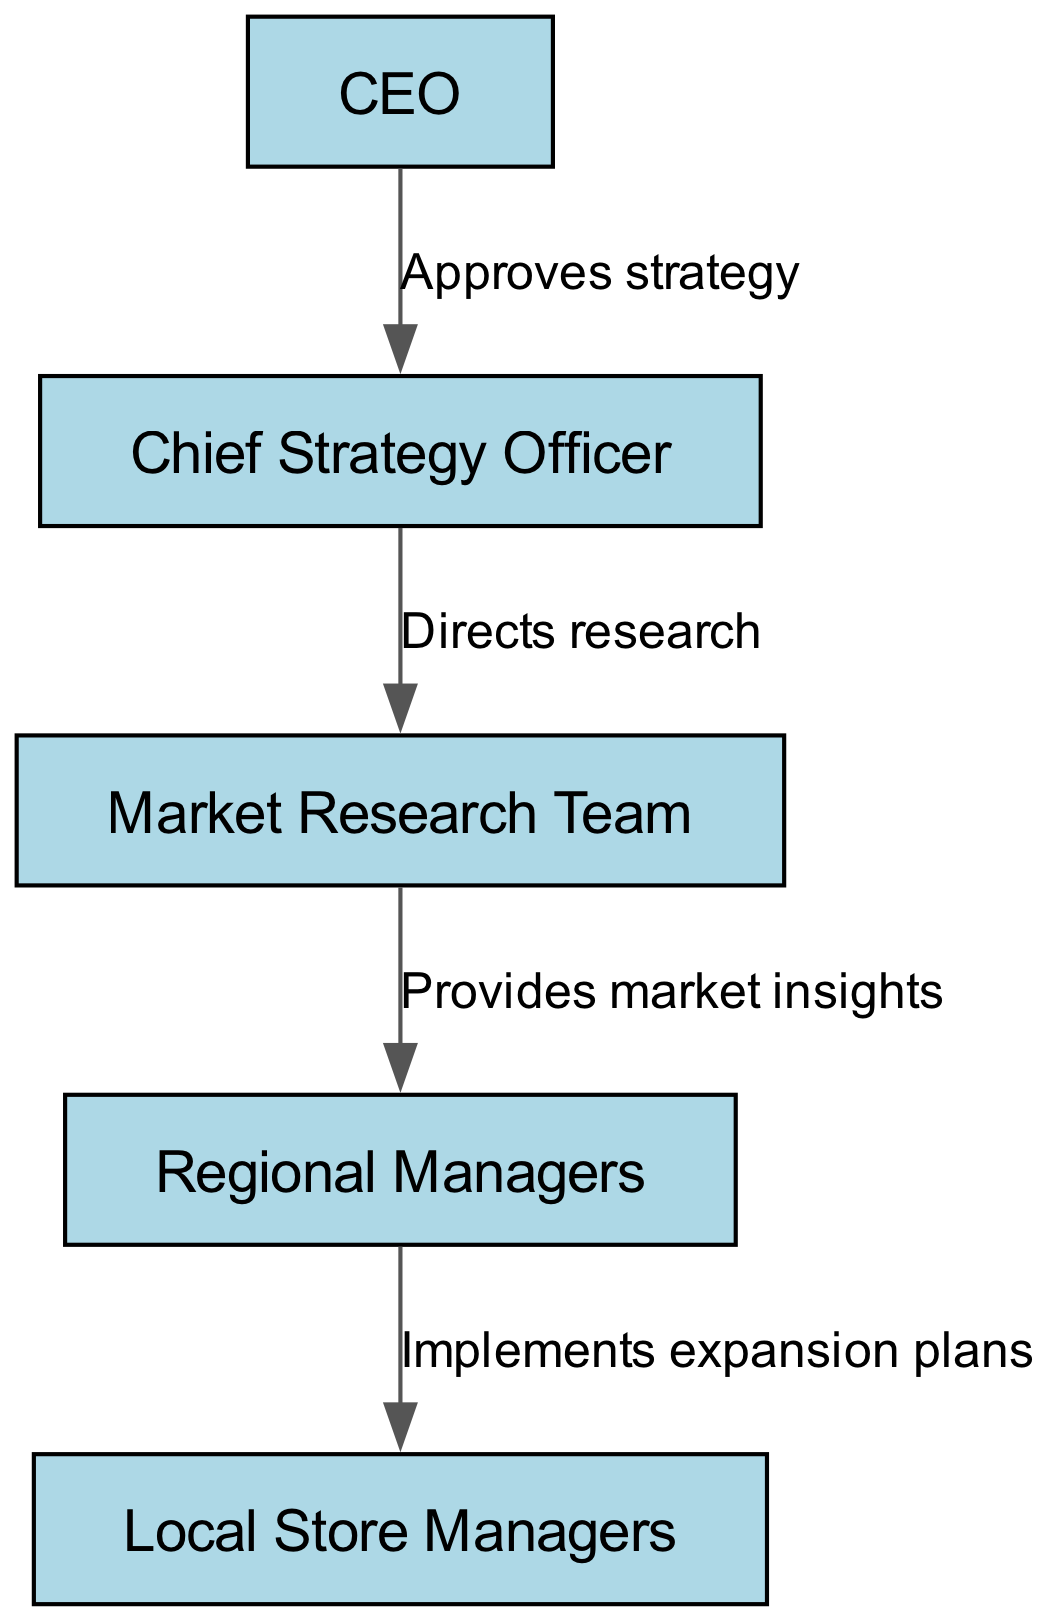What is the top position in the hierarchy? The top position is represented as the CEO, who is the first node in the diagram.
Answer: CEO How many nodes are in the diagram? The diagram includes a total of 5 nodes, representing different levels of decision-makers.
Answer: 5 What is the role of the Chief Strategy Officer? The Chief Strategy Officer's role is to direct research, indicated by the edge connecting them to the Market Research Team.
Answer: Directs research Who implements the expansion plans? Local Store Managers are responsible for implementing the expansion plans as shown by the edge leading from Regional Managers to Local Store Managers.
Answer: Local Store Managers What is the relationship between the CEO and the Chief Strategy Officer? The relationship is that the CEO approves the strategy, which is identified by the edge describing that connection.
Answer: Approves strategy What information does the Market Research Team provide? The Market Research Team provides market insights to the Regional Managers, evidenced by the labeled edge between them.
Answer: Provides market insights Which position receives insights from the Market Research Team? The Regional Managers receive insights from the Market Research Team, as seen in the directed flow of information in the diagram.
Answer: Regional Managers Who is responsible for the final implementation of market expansion plans? The Local Store Managers are responsible for the final implementation as they are at the end of the flow from the Regional Managers.
Answer: Local Store Managers How does information flow from the CEO down to the Local Store Managers? The information flow starts with the CEO approving the strategy, which directs the research by the Chief Strategy Officer, who then has the Market Research Team provide insights to Regional Managers, culminating in the implementation by Local Store Managers.
Answer: CEO → Chief Strategy Officer → Market Research Team → Regional Managers → Local Store Managers 